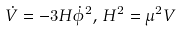<formula> <loc_0><loc_0><loc_500><loc_500>\dot { V } = - 3 H \dot { \phi } ^ { 2 } , \, H ^ { 2 } = \mu ^ { 2 } V</formula> 